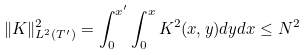Convert formula to latex. <formula><loc_0><loc_0><loc_500><loc_500>\| K \| ^ { 2 } _ { L ^ { 2 } ( T ^ { \prime } ) } = \int _ { 0 } ^ { x ^ { \prime } } \int _ { 0 } ^ { x } K ^ { 2 } ( x , y ) d y d x \leq N ^ { 2 }</formula> 